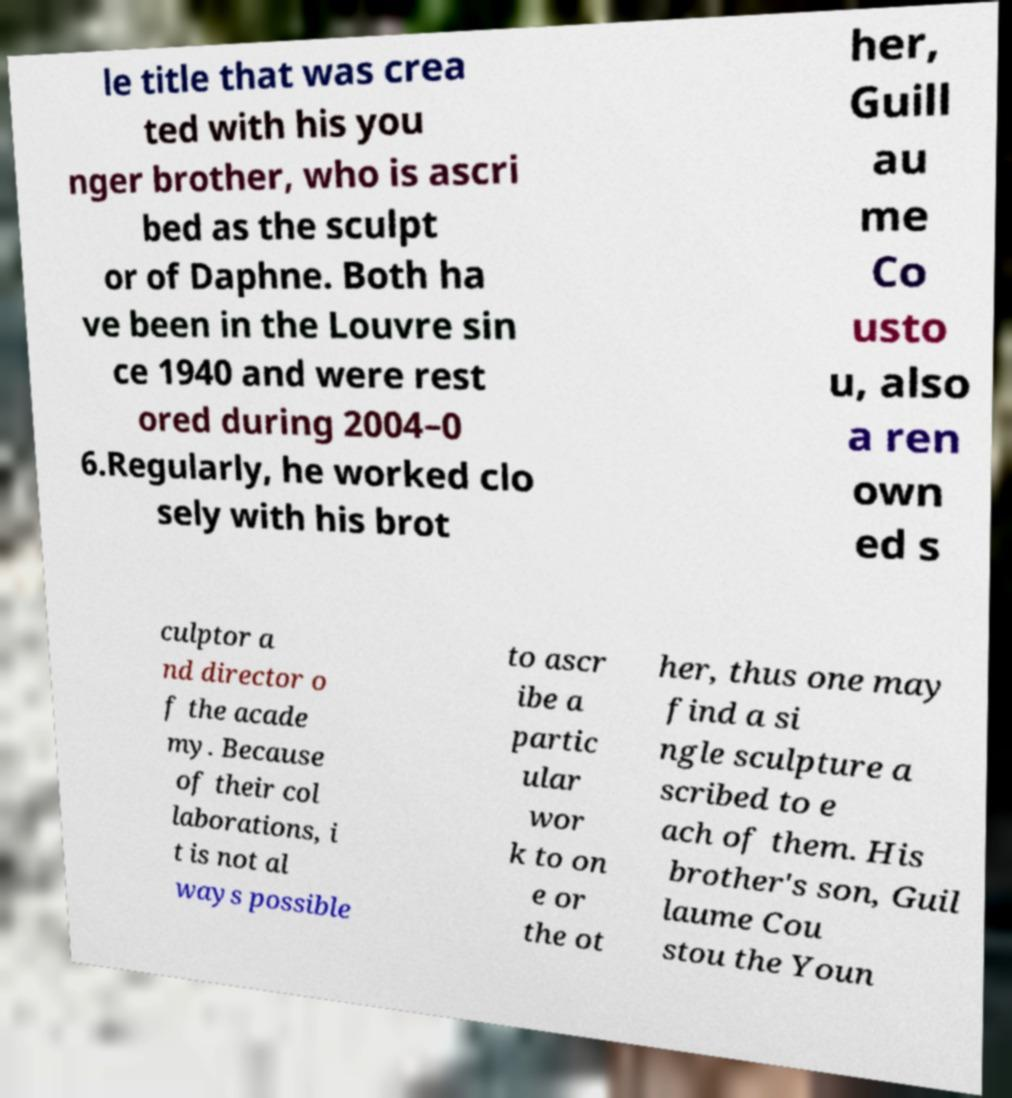Can you accurately transcribe the text from the provided image for me? le title that was crea ted with his you nger brother, who is ascri bed as the sculpt or of Daphne. Both ha ve been in the Louvre sin ce 1940 and were rest ored during 2004–0 6.Regularly, he worked clo sely with his brot her, Guill au me Co usto u, also a ren own ed s culptor a nd director o f the acade my. Because of their col laborations, i t is not al ways possible to ascr ibe a partic ular wor k to on e or the ot her, thus one may find a si ngle sculpture a scribed to e ach of them. His brother's son, Guil laume Cou stou the Youn 